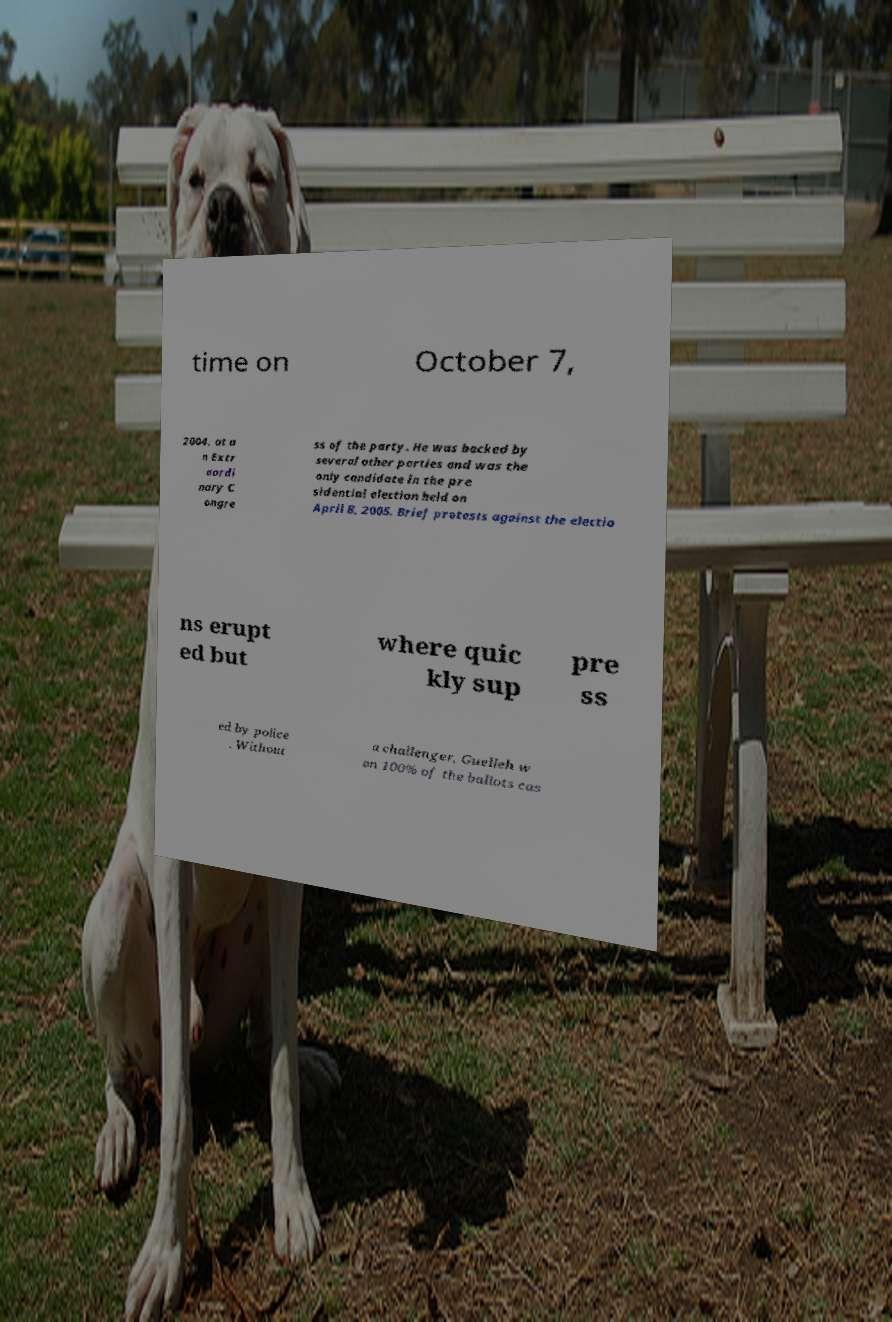Can you accurately transcribe the text from the provided image for me? time on October 7, 2004, at a n Extr aordi nary C ongre ss of the party. He was backed by several other parties and was the only candidate in the pre sidential election held on April 8, 2005. Brief protests against the electio ns erupt ed but where quic kly sup pre ss ed by police . Without a challenger, Guelleh w on 100% of the ballots cas 